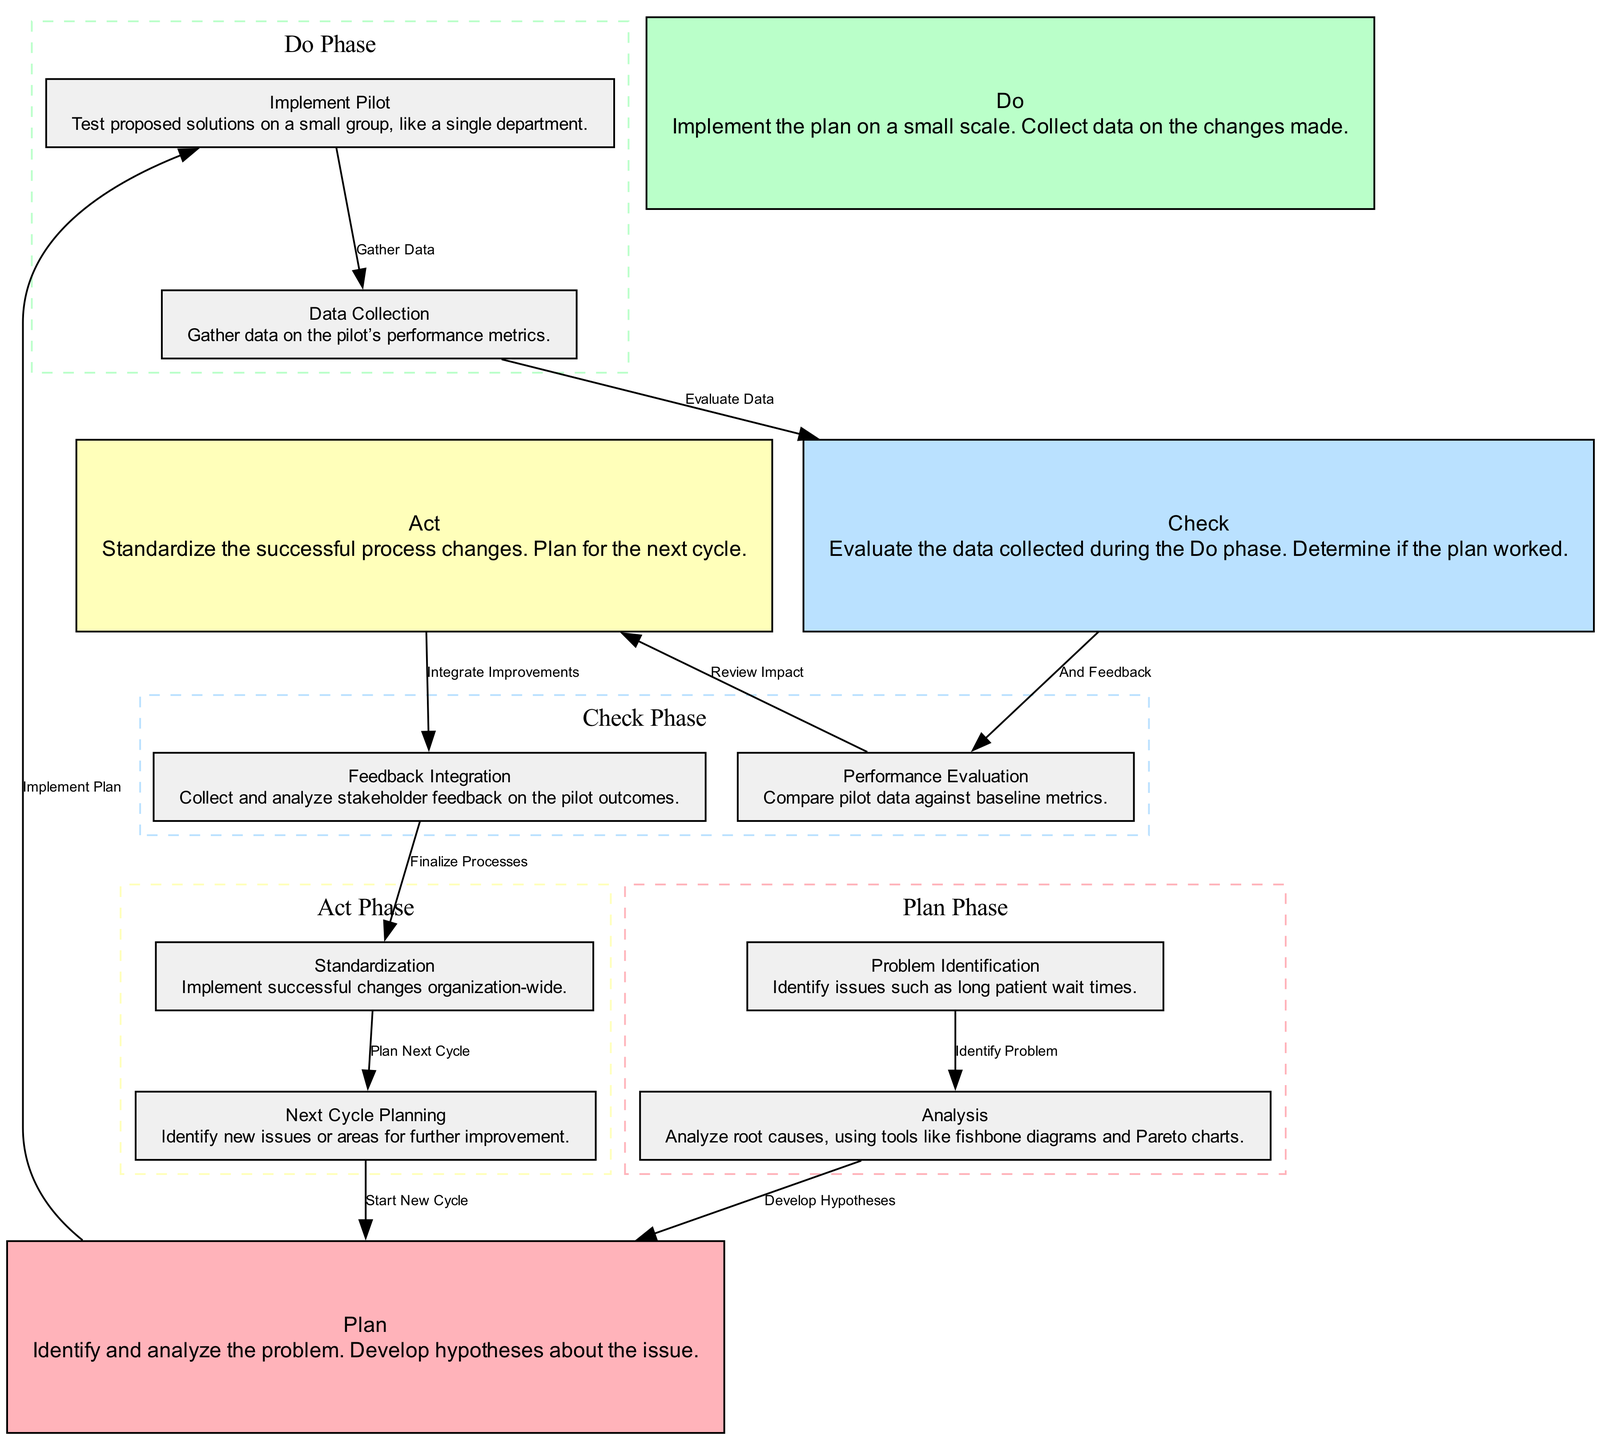What is the first phase in the PDCA cycle? The diagram starts with the "Plan" phase, indicating it is the initial step in the PDCA cycle.
Answer: Plan How many nodes are present in the diagram? By counting the nodes listed in the data, we see there are 12 distinct nodes representing different phases and actions in the PDCA cycle.
Answer: 12 What is the outcome after the "Act" phase? The diagram shows "Feedback Integration" follows the "Act" phase, indicating that this is the next step after standardizing successful process changes.
Answer: Feedback Integration Which phase involves collecting data on pilot performance? The "Do" phase contains the "Data Collection" step, which explicitly states that this phase entails gathering data on the performance metrics of the pilot implementation.
Answer: Do What processes lead to the "Standardization" phase? The path from "Act" to "Feedback Integration" followed by an arrow to "Standardization" indicates the steps taken to integrate feedback before standardizing successful changes.
Answer: Act, Feedback Integration How does "Analysis" relate to "Plan"? "Analysis" comes before "Plan" in the diagram, as the insights gained from analyzing root causes help develop hypotheses, which are central to planning.
Answer: Develop Hypotheses What is a tool mentioned for the analysis of root causes? The diagram specifies using "tools like fishbone diagrams and Pareto charts" during the "Analysis" phase for analyzing the identified problem's root causes.
Answer: Fishbone diagrams and Pareto charts What action follows "Data Collection" in the cycle? After "Data Collection," the next step indicated in the diagram is "Check," which suggests evaluating the data gathered from the pilot implementation.
Answer: Check How many phases are outlined in the PDCA cycle? The diagram delineates four main phases: "Plan," "Do," "Check," and "Act," making a total of four distinct phases in the PDCA cycle.
Answer: 4 